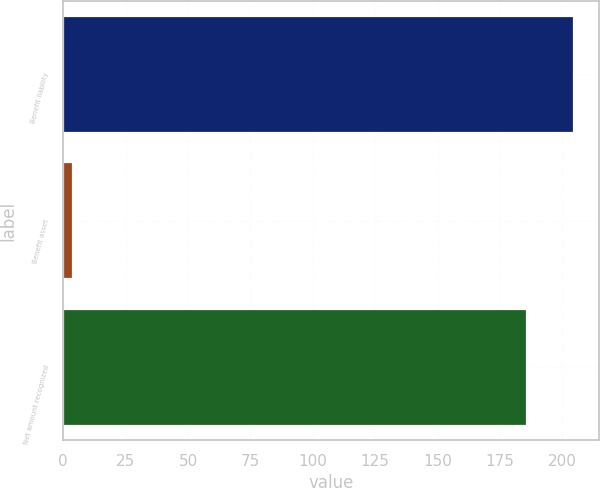Convert chart to OTSL. <chart><loc_0><loc_0><loc_500><loc_500><bar_chart><fcel>Benefit liability<fcel>Benefit asset<fcel>Net amount recognized<nl><fcel>204.6<fcel>4<fcel>186<nl></chart> 